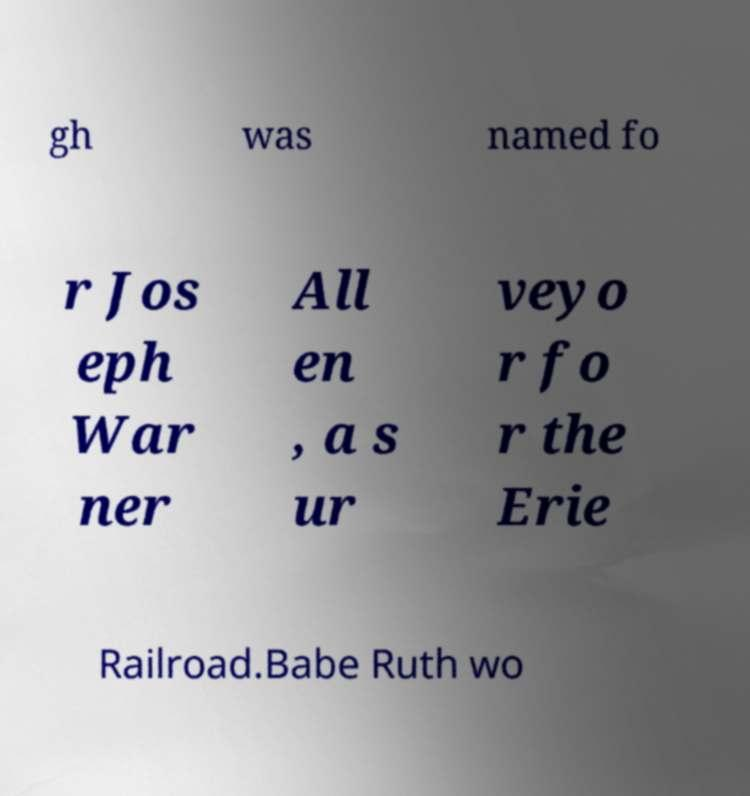What messages or text are displayed in this image? I need them in a readable, typed format. gh was named fo r Jos eph War ner All en , a s ur veyo r fo r the Erie Railroad.Babe Ruth wo 